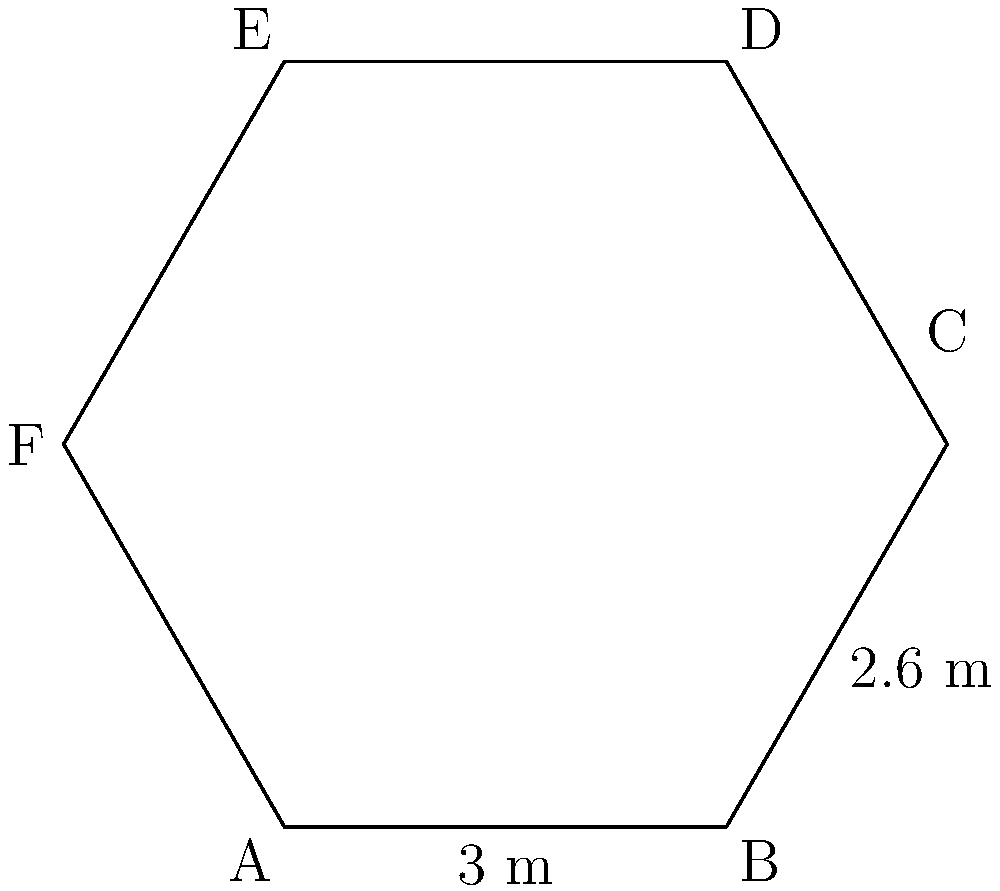As part of a vaccination campaign in Indonesia, you are designing a hexagonal vaccination booth layout. The hexagon has two parallel sides of 3 meters each, and the distance between these parallel sides is 5.2 meters. If the length of one of the other sides is 2.6 meters, calculate the perimeter of the entire hexagonal layout. Let's approach this step-by-step:

1) In a regular hexagon, all sides are equal. However, this is not a regular hexagon, so we need to calculate the unknown sides.

2) We know that two parallel sides are 3 meters each, and one of the other sides is 2.6 meters.

3) Due to the symmetry of a hexagon, the side opposite to the known 2.6-meter side will also be 2.6 meters.

4) Now we need to calculate the remaining two sides. We can do this using the Pythagorean theorem.

5) Half of the distance between the parallel sides is 5.2/2 = 2.6 meters.

6) Using the Pythagorean theorem:
   $x^2 + 2.6^2 = 3^2$
   Where $x$ is half of the unknown side length.

7) Solving for $x$:
   $x^2 = 3^2 - 2.6^2 = 9 - 6.76 = 2.24$
   $x = \sqrt{2.24} = 1.5$ meters

8) The full length of this side is $2 * 1.5 = 3$ meters

9) Now we have all the side lengths: 3, 2.6, 3, 3, 2.6, 3 meters

10) The perimeter is the sum of all sides:
    $3 + 2.6 + 3 + 3 + 2.6 + 3 = 17.2$ meters

Therefore, the perimeter of the hexagonal vaccination booth layout is 17.2 meters.
Answer: 17.2 meters 